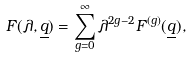Convert formula to latex. <formula><loc_0><loc_0><loc_500><loc_500>F ( \lambda , \underline { q } ) = \sum _ { g = 0 } ^ { \infty } \lambda ^ { 2 g - 2 } F ^ { ( g ) } ( \underline { q } ) ,</formula> 